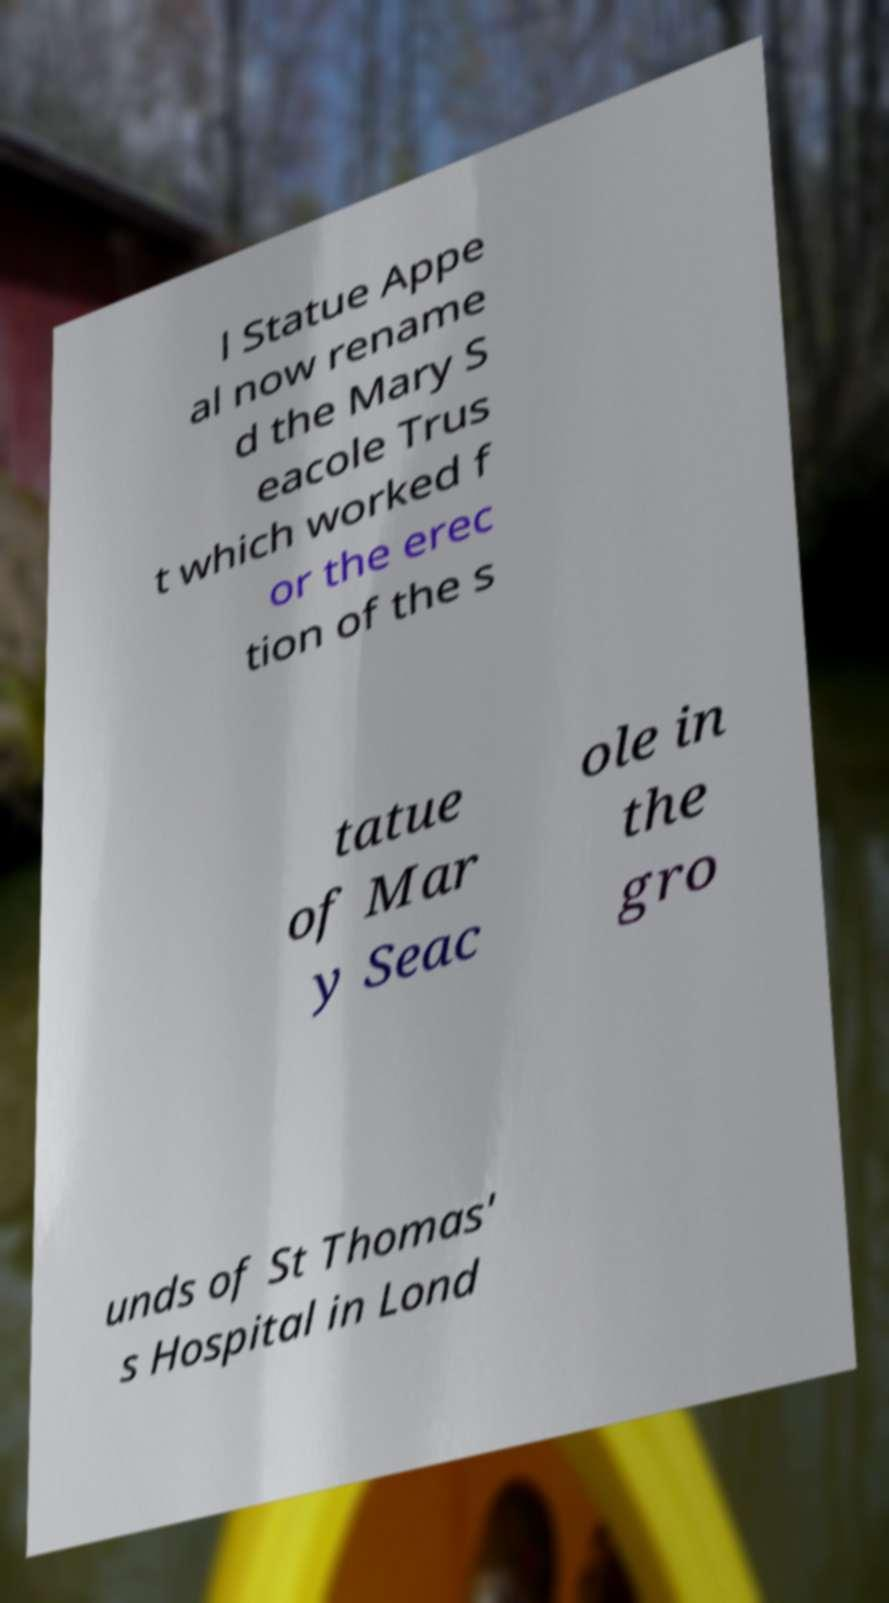There's text embedded in this image that I need extracted. Can you transcribe it verbatim? l Statue Appe al now rename d the Mary S eacole Trus t which worked f or the erec tion of the s tatue of Mar y Seac ole in the gro unds of St Thomas' s Hospital in Lond 